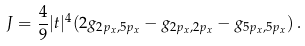<formula> <loc_0><loc_0><loc_500><loc_500>J = \frac { 4 } { 9 } | t | ^ { 4 } ( 2 g _ { 2 p _ { x } , 5 p _ { x } } - g _ { 2 p _ { x } , 2 p _ { x } } - g _ { 5 p _ { x } , 5 p _ { x } } ) \, .</formula> 